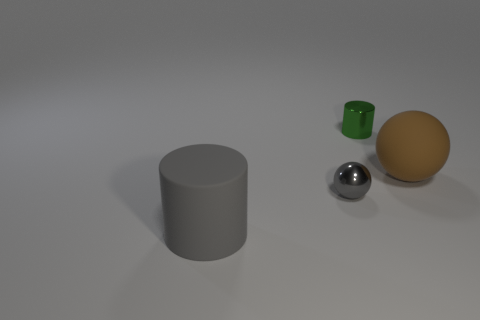What number of tiny gray objects are behind the tiny gray metallic ball?
Give a very brief answer. 0. What shape is the thing on the left side of the gray thing that is on the right side of the gray matte cylinder?
Make the answer very short. Cylinder. Are there any other things that have the same shape as the gray rubber thing?
Make the answer very short. Yes. Is the number of matte objects left of the big gray matte object greater than the number of blue blocks?
Keep it short and to the point. No. How many brown matte things are in front of the cylinder that is behind the gray rubber cylinder?
Make the answer very short. 1. What shape is the big thing that is on the right side of the gray ball that is left of the small green metallic cylinder on the right side of the rubber cylinder?
Ensure brevity in your answer.  Sphere. What size is the gray rubber cylinder?
Keep it short and to the point. Large. Are there any tiny things made of the same material as the green cylinder?
Provide a succinct answer. Yes. There is another object that is the same shape as the small gray thing; what size is it?
Your answer should be compact. Large. Are there an equal number of gray metallic balls that are on the right side of the tiny shiny cylinder and green metallic cylinders?
Give a very brief answer. No. 